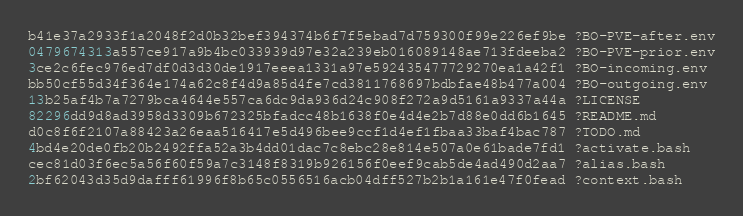<code> <loc_0><loc_0><loc_500><loc_500><_SML_>b41e37a2933f1a2048f2d0b32bef394374b6f7f5ebad7d759300f99e226ef9be ?BO-PVE-after.env
0479674313a557ce917a9b4bc033939d97e32a239eb016089148ae713fdeeba2 ?BO-PVE-prior.env
3ce2c6fec976ed7df0d3d30de1917eeea1331a97e592435477729270ea1a42f1 ?BO-incoming.env
bb50cf55d34f364e174a62c8f4d9a85d4fe7cd3811768697bdbfae48b477a004 ?BO-outgoing.env
13b25af4b7a7279bca4644e557ca6dc9da936d24c908f272a9d5161a9337a44a ?LICENSE
82296dd9d8ad3958d3309b672325bfadcc48b1638f0e4d4e2b7d88e0dd6b1645 ?README.md
d0c8f6f2107a88423a26eaa516417e5d496bee9ccf1d4ef1fbaa33baf4bac787 ?TODO.md
4bd4e20de0fb20b2492ffa52a3b4dd01dac7c8ebc28e814e507a0e61bade7fd1 ?activate.bash
cec81d03f6ec5a56f60f59a7c3148f8319b926156f0eef9cab5de4ad490d2aa7 ?alias.bash
2bf62043d35d9dafff61996f8b65c0556516acb04dff527b2b1a161e47f0fead ?context.bash
</code> 